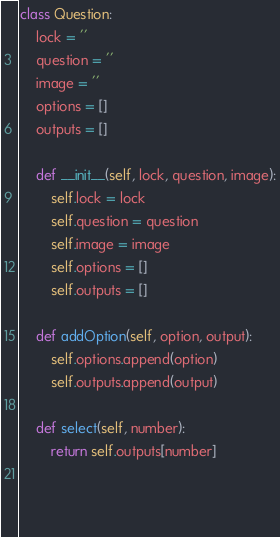Convert code to text. <code><loc_0><loc_0><loc_500><loc_500><_Python_>class Question:
    lock = ''
    question = ''
    image = ''
    options = []
    outputs = []

    def __init__(self, lock, question, image):
        self.lock = lock
        self.question = question
        self.image = image
        self.options = []
        self.outputs = []

    def addOption(self, option, output):
        self.options.append(option)
        self.outputs.append(output)

    def select(self, number):
        return self.outputs[number]
    
    
    
</code> 